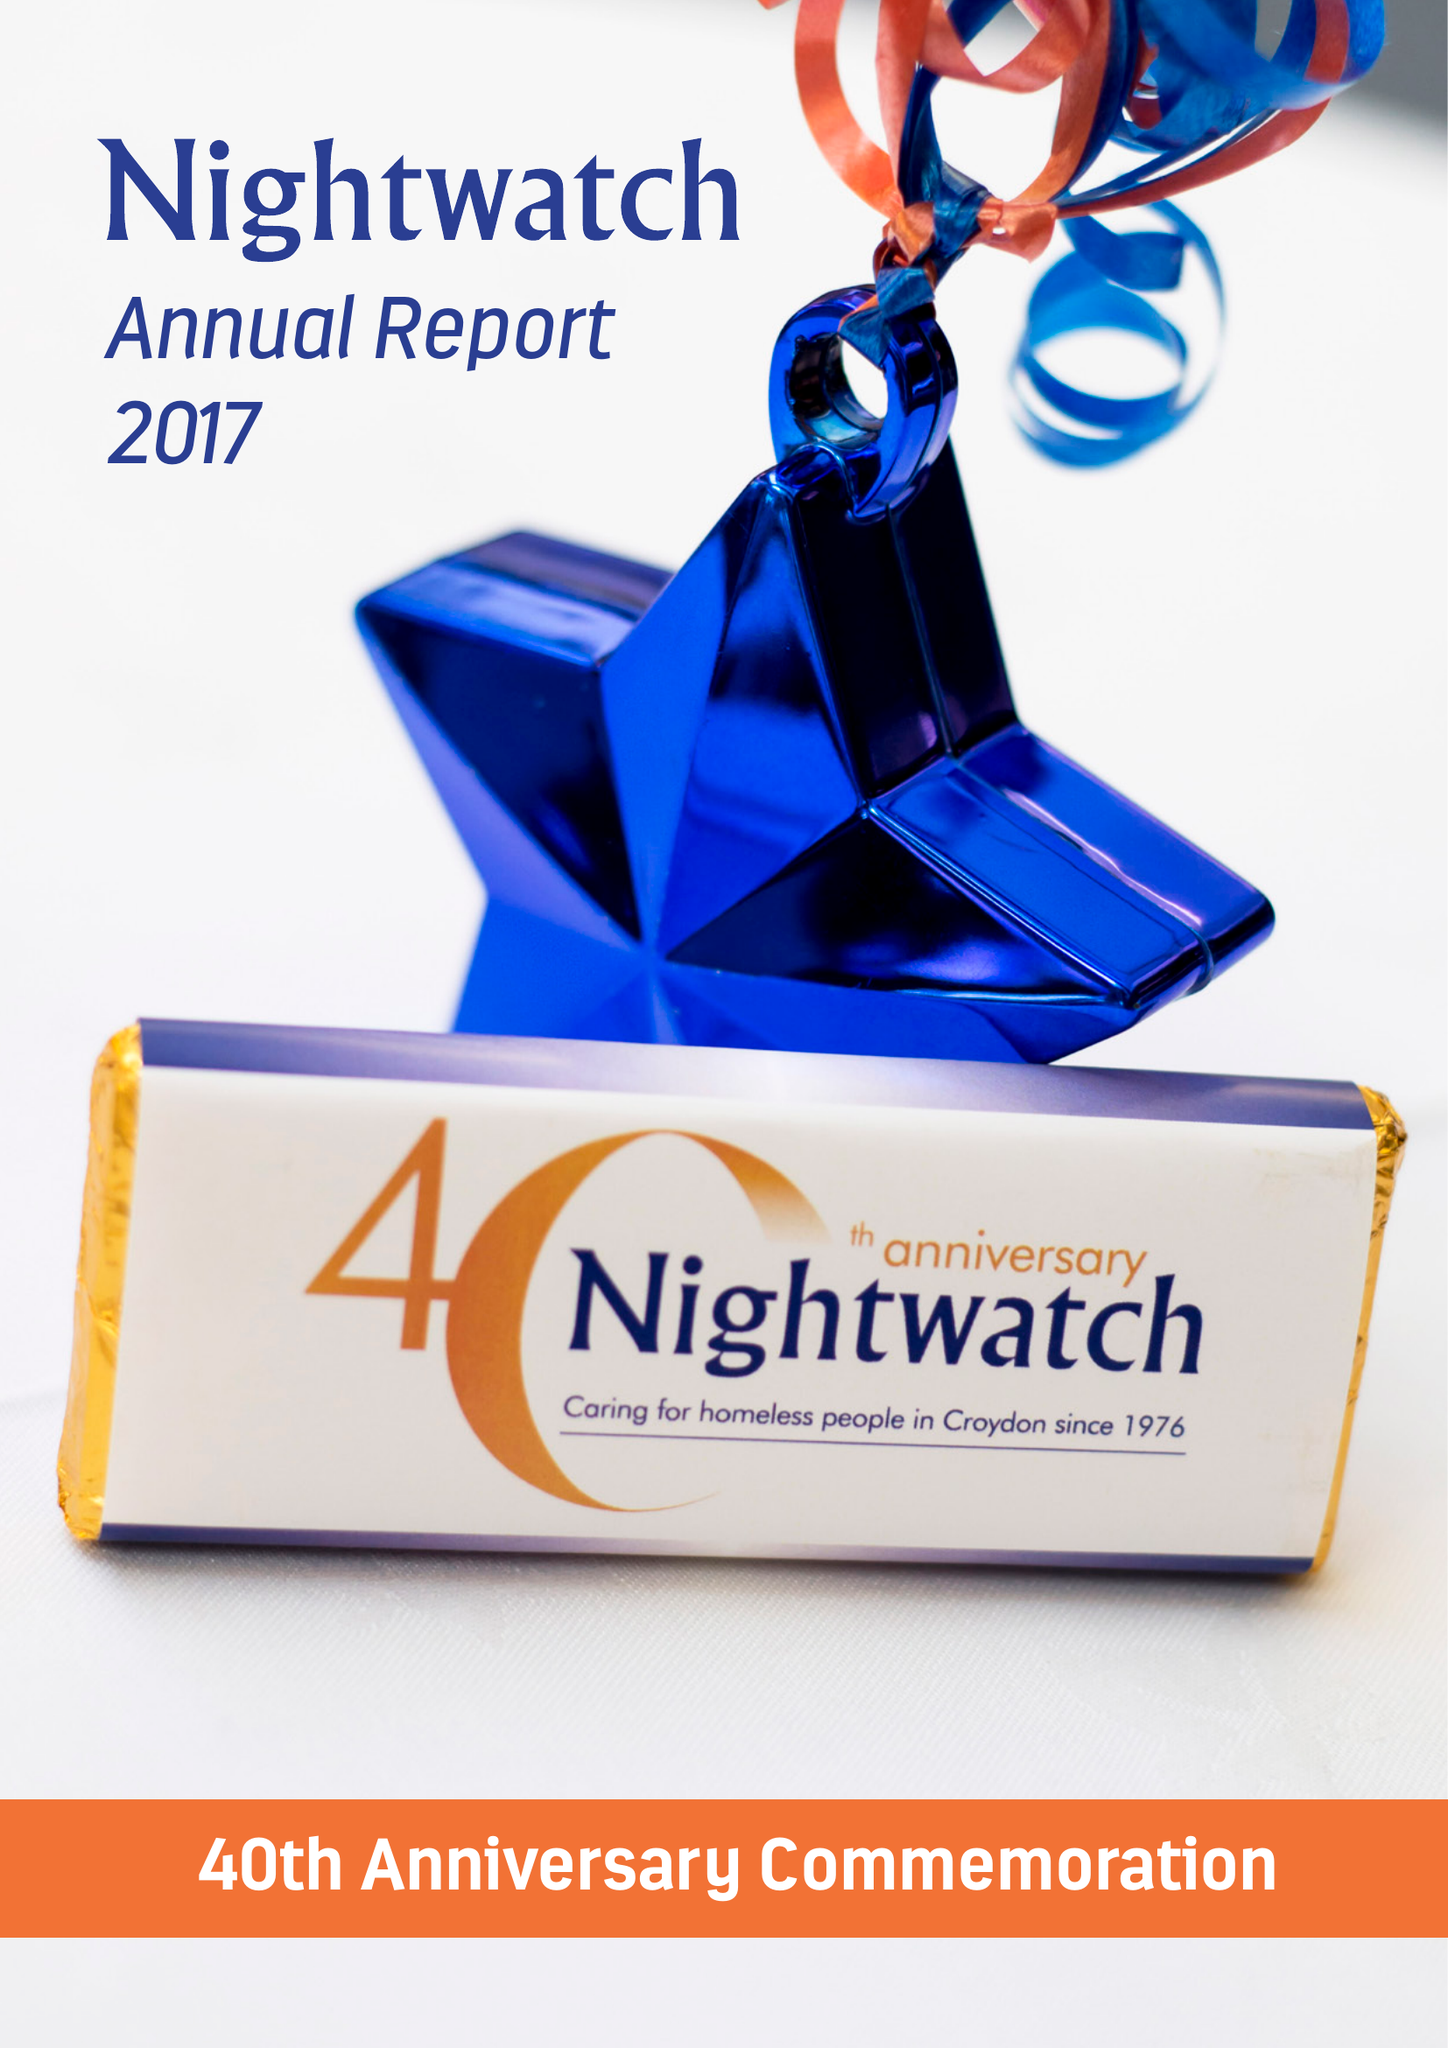What is the value for the report_date?
Answer the question using a single word or phrase. 2016-12-31 